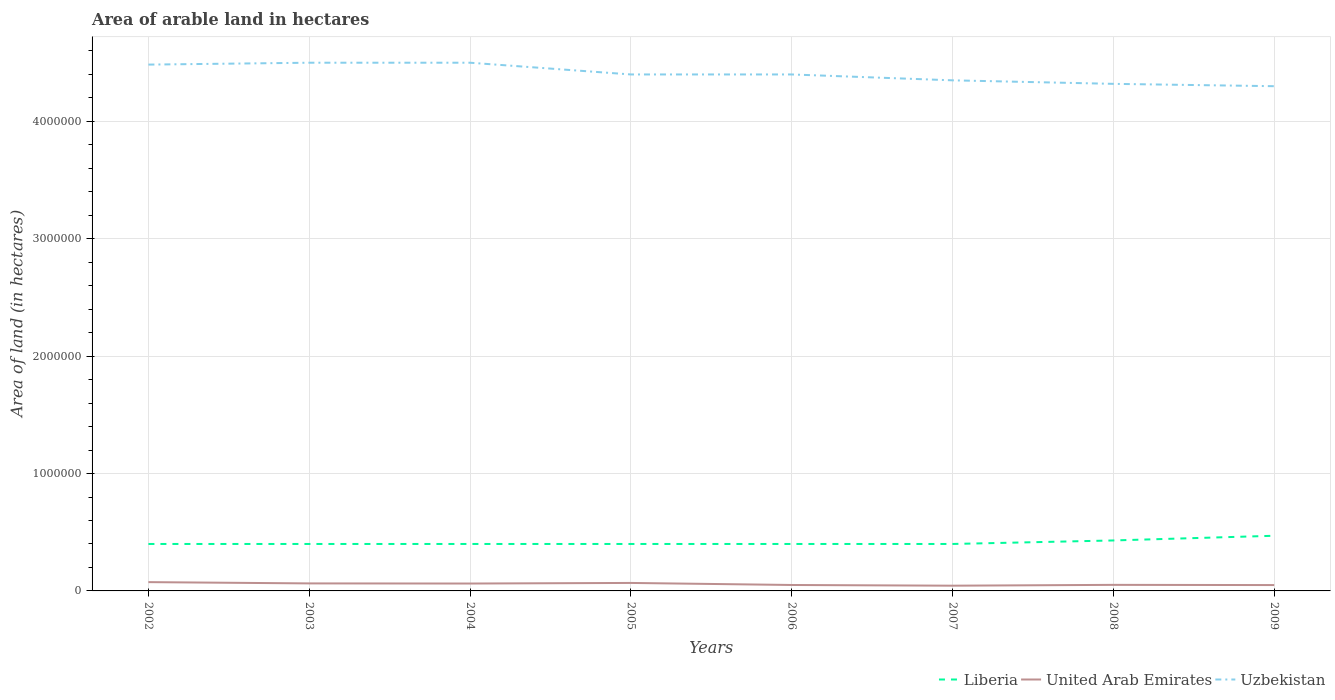Across all years, what is the maximum total arable land in United Arab Emirates?
Ensure brevity in your answer.  4.46e+04. What is the total total arable land in United Arab Emirates in the graph?
Keep it short and to the point. 1700. What is the difference between the highest and the second highest total arable land in Liberia?
Offer a very short reply. 7.00e+04. What is the difference between the highest and the lowest total arable land in Liberia?
Provide a succinct answer. 2. How many lines are there?
Give a very brief answer. 3. What is the difference between two consecutive major ticks on the Y-axis?
Your answer should be compact. 1.00e+06. Does the graph contain any zero values?
Your answer should be compact. No. How many legend labels are there?
Your answer should be compact. 3. How are the legend labels stacked?
Make the answer very short. Horizontal. What is the title of the graph?
Your answer should be compact. Area of arable land in hectares. What is the label or title of the X-axis?
Offer a very short reply. Years. What is the label or title of the Y-axis?
Your answer should be very brief. Area of land (in hectares). What is the Area of land (in hectares) of Liberia in 2002?
Your response must be concise. 4.00e+05. What is the Area of land (in hectares) of United Arab Emirates in 2002?
Keep it short and to the point. 7.50e+04. What is the Area of land (in hectares) of Uzbekistan in 2002?
Keep it short and to the point. 4.48e+06. What is the Area of land (in hectares) in Liberia in 2003?
Provide a succinct answer. 4.00e+05. What is the Area of land (in hectares) in United Arab Emirates in 2003?
Ensure brevity in your answer.  6.40e+04. What is the Area of land (in hectares) of Uzbekistan in 2003?
Keep it short and to the point. 4.50e+06. What is the Area of land (in hectares) in Liberia in 2004?
Provide a succinct answer. 4.00e+05. What is the Area of land (in hectares) in United Arab Emirates in 2004?
Your response must be concise. 6.30e+04. What is the Area of land (in hectares) in Uzbekistan in 2004?
Offer a terse response. 4.50e+06. What is the Area of land (in hectares) of Liberia in 2005?
Offer a terse response. 4.00e+05. What is the Area of land (in hectares) in United Arab Emirates in 2005?
Your response must be concise. 6.80e+04. What is the Area of land (in hectares) in Uzbekistan in 2005?
Provide a succinct answer. 4.40e+06. What is the Area of land (in hectares) in Liberia in 2006?
Your answer should be very brief. 4.00e+05. What is the Area of land (in hectares) of United Arab Emirates in 2006?
Provide a short and direct response. 5.06e+04. What is the Area of land (in hectares) of Uzbekistan in 2006?
Provide a succinct answer. 4.40e+06. What is the Area of land (in hectares) of Liberia in 2007?
Provide a short and direct response. 4.00e+05. What is the Area of land (in hectares) of United Arab Emirates in 2007?
Your response must be concise. 4.46e+04. What is the Area of land (in hectares) in Uzbekistan in 2007?
Provide a succinct answer. 4.35e+06. What is the Area of land (in hectares) of United Arab Emirates in 2008?
Give a very brief answer. 5.16e+04. What is the Area of land (in hectares) in Uzbekistan in 2008?
Provide a short and direct response. 4.32e+06. What is the Area of land (in hectares) in Liberia in 2009?
Ensure brevity in your answer.  4.70e+05. What is the Area of land (in hectares) of United Arab Emirates in 2009?
Offer a terse response. 4.99e+04. What is the Area of land (in hectares) in Uzbekistan in 2009?
Ensure brevity in your answer.  4.30e+06. Across all years, what is the maximum Area of land (in hectares) in United Arab Emirates?
Offer a very short reply. 7.50e+04. Across all years, what is the maximum Area of land (in hectares) in Uzbekistan?
Your answer should be compact. 4.50e+06. Across all years, what is the minimum Area of land (in hectares) of United Arab Emirates?
Ensure brevity in your answer.  4.46e+04. Across all years, what is the minimum Area of land (in hectares) in Uzbekistan?
Provide a short and direct response. 4.30e+06. What is the total Area of land (in hectares) of Liberia in the graph?
Make the answer very short. 3.30e+06. What is the total Area of land (in hectares) in United Arab Emirates in the graph?
Your answer should be compact. 4.67e+05. What is the total Area of land (in hectares) in Uzbekistan in the graph?
Ensure brevity in your answer.  3.53e+07. What is the difference between the Area of land (in hectares) in Liberia in 2002 and that in 2003?
Provide a succinct answer. 0. What is the difference between the Area of land (in hectares) in United Arab Emirates in 2002 and that in 2003?
Give a very brief answer. 1.10e+04. What is the difference between the Area of land (in hectares) of Uzbekistan in 2002 and that in 2003?
Offer a terse response. -1.60e+04. What is the difference between the Area of land (in hectares) of Liberia in 2002 and that in 2004?
Make the answer very short. 0. What is the difference between the Area of land (in hectares) in United Arab Emirates in 2002 and that in 2004?
Give a very brief answer. 1.20e+04. What is the difference between the Area of land (in hectares) of Uzbekistan in 2002 and that in 2004?
Your answer should be very brief. -1.60e+04. What is the difference between the Area of land (in hectares) of United Arab Emirates in 2002 and that in 2005?
Your answer should be very brief. 7000. What is the difference between the Area of land (in hectares) in Uzbekistan in 2002 and that in 2005?
Offer a very short reply. 8.40e+04. What is the difference between the Area of land (in hectares) in Liberia in 2002 and that in 2006?
Your response must be concise. 0. What is the difference between the Area of land (in hectares) in United Arab Emirates in 2002 and that in 2006?
Ensure brevity in your answer.  2.44e+04. What is the difference between the Area of land (in hectares) in Uzbekistan in 2002 and that in 2006?
Make the answer very short. 8.40e+04. What is the difference between the Area of land (in hectares) in United Arab Emirates in 2002 and that in 2007?
Offer a terse response. 3.04e+04. What is the difference between the Area of land (in hectares) in Uzbekistan in 2002 and that in 2007?
Offer a terse response. 1.34e+05. What is the difference between the Area of land (in hectares) in United Arab Emirates in 2002 and that in 2008?
Give a very brief answer. 2.34e+04. What is the difference between the Area of land (in hectares) of Uzbekistan in 2002 and that in 2008?
Offer a terse response. 1.64e+05. What is the difference between the Area of land (in hectares) of United Arab Emirates in 2002 and that in 2009?
Your answer should be very brief. 2.51e+04. What is the difference between the Area of land (in hectares) in Uzbekistan in 2002 and that in 2009?
Your answer should be very brief. 1.84e+05. What is the difference between the Area of land (in hectares) of Liberia in 2003 and that in 2004?
Your response must be concise. 0. What is the difference between the Area of land (in hectares) in Liberia in 2003 and that in 2005?
Ensure brevity in your answer.  0. What is the difference between the Area of land (in hectares) in United Arab Emirates in 2003 and that in 2005?
Your answer should be very brief. -4000. What is the difference between the Area of land (in hectares) in Uzbekistan in 2003 and that in 2005?
Provide a short and direct response. 1.00e+05. What is the difference between the Area of land (in hectares) of United Arab Emirates in 2003 and that in 2006?
Offer a terse response. 1.34e+04. What is the difference between the Area of land (in hectares) in Uzbekistan in 2003 and that in 2006?
Make the answer very short. 1.00e+05. What is the difference between the Area of land (in hectares) of Liberia in 2003 and that in 2007?
Provide a short and direct response. 0. What is the difference between the Area of land (in hectares) of United Arab Emirates in 2003 and that in 2007?
Your response must be concise. 1.94e+04. What is the difference between the Area of land (in hectares) in United Arab Emirates in 2003 and that in 2008?
Provide a short and direct response. 1.24e+04. What is the difference between the Area of land (in hectares) of Uzbekistan in 2003 and that in 2008?
Keep it short and to the point. 1.80e+05. What is the difference between the Area of land (in hectares) of United Arab Emirates in 2003 and that in 2009?
Provide a short and direct response. 1.41e+04. What is the difference between the Area of land (in hectares) in Uzbekistan in 2003 and that in 2009?
Make the answer very short. 2.00e+05. What is the difference between the Area of land (in hectares) in United Arab Emirates in 2004 and that in 2005?
Ensure brevity in your answer.  -5000. What is the difference between the Area of land (in hectares) in Uzbekistan in 2004 and that in 2005?
Make the answer very short. 1.00e+05. What is the difference between the Area of land (in hectares) of United Arab Emirates in 2004 and that in 2006?
Offer a very short reply. 1.24e+04. What is the difference between the Area of land (in hectares) in Liberia in 2004 and that in 2007?
Give a very brief answer. 0. What is the difference between the Area of land (in hectares) in United Arab Emirates in 2004 and that in 2007?
Provide a succinct answer. 1.84e+04. What is the difference between the Area of land (in hectares) in Uzbekistan in 2004 and that in 2007?
Provide a short and direct response. 1.50e+05. What is the difference between the Area of land (in hectares) in Liberia in 2004 and that in 2008?
Ensure brevity in your answer.  -3.00e+04. What is the difference between the Area of land (in hectares) of United Arab Emirates in 2004 and that in 2008?
Keep it short and to the point. 1.14e+04. What is the difference between the Area of land (in hectares) in Uzbekistan in 2004 and that in 2008?
Provide a succinct answer. 1.80e+05. What is the difference between the Area of land (in hectares) in United Arab Emirates in 2004 and that in 2009?
Keep it short and to the point. 1.31e+04. What is the difference between the Area of land (in hectares) in Uzbekistan in 2004 and that in 2009?
Your answer should be compact. 2.00e+05. What is the difference between the Area of land (in hectares) in United Arab Emirates in 2005 and that in 2006?
Offer a terse response. 1.74e+04. What is the difference between the Area of land (in hectares) in United Arab Emirates in 2005 and that in 2007?
Provide a short and direct response. 2.34e+04. What is the difference between the Area of land (in hectares) in Uzbekistan in 2005 and that in 2007?
Offer a very short reply. 5.00e+04. What is the difference between the Area of land (in hectares) in Liberia in 2005 and that in 2008?
Your response must be concise. -3.00e+04. What is the difference between the Area of land (in hectares) in United Arab Emirates in 2005 and that in 2008?
Make the answer very short. 1.64e+04. What is the difference between the Area of land (in hectares) in Liberia in 2005 and that in 2009?
Offer a very short reply. -7.00e+04. What is the difference between the Area of land (in hectares) in United Arab Emirates in 2005 and that in 2009?
Provide a short and direct response. 1.81e+04. What is the difference between the Area of land (in hectares) of United Arab Emirates in 2006 and that in 2007?
Your answer should be very brief. 6000. What is the difference between the Area of land (in hectares) in Liberia in 2006 and that in 2008?
Your response must be concise. -3.00e+04. What is the difference between the Area of land (in hectares) in United Arab Emirates in 2006 and that in 2008?
Your answer should be very brief. -1000. What is the difference between the Area of land (in hectares) in Liberia in 2006 and that in 2009?
Offer a terse response. -7.00e+04. What is the difference between the Area of land (in hectares) of United Arab Emirates in 2006 and that in 2009?
Your answer should be very brief. 700. What is the difference between the Area of land (in hectares) in United Arab Emirates in 2007 and that in 2008?
Offer a terse response. -7000. What is the difference between the Area of land (in hectares) in Uzbekistan in 2007 and that in 2008?
Offer a terse response. 3.00e+04. What is the difference between the Area of land (in hectares) of United Arab Emirates in 2007 and that in 2009?
Provide a short and direct response. -5300. What is the difference between the Area of land (in hectares) in United Arab Emirates in 2008 and that in 2009?
Ensure brevity in your answer.  1700. What is the difference between the Area of land (in hectares) of Liberia in 2002 and the Area of land (in hectares) of United Arab Emirates in 2003?
Provide a succinct answer. 3.36e+05. What is the difference between the Area of land (in hectares) in Liberia in 2002 and the Area of land (in hectares) in Uzbekistan in 2003?
Provide a short and direct response. -4.10e+06. What is the difference between the Area of land (in hectares) of United Arab Emirates in 2002 and the Area of land (in hectares) of Uzbekistan in 2003?
Your response must be concise. -4.42e+06. What is the difference between the Area of land (in hectares) in Liberia in 2002 and the Area of land (in hectares) in United Arab Emirates in 2004?
Offer a terse response. 3.37e+05. What is the difference between the Area of land (in hectares) in Liberia in 2002 and the Area of land (in hectares) in Uzbekistan in 2004?
Make the answer very short. -4.10e+06. What is the difference between the Area of land (in hectares) in United Arab Emirates in 2002 and the Area of land (in hectares) in Uzbekistan in 2004?
Provide a succinct answer. -4.42e+06. What is the difference between the Area of land (in hectares) in Liberia in 2002 and the Area of land (in hectares) in United Arab Emirates in 2005?
Offer a terse response. 3.32e+05. What is the difference between the Area of land (in hectares) of Liberia in 2002 and the Area of land (in hectares) of Uzbekistan in 2005?
Your response must be concise. -4.00e+06. What is the difference between the Area of land (in hectares) in United Arab Emirates in 2002 and the Area of land (in hectares) in Uzbekistan in 2005?
Offer a very short reply. -4.32e+06. What is the difference between the Area of land (in hectares) of Liberia in 2002 and the Area of land (in hectares) of United Arab Emirates in 2006?
Make the answer very short. 3.49e+05. What is the difference between the Area of land (in hectares) of Liberia in 2002 and the Area of land (in hectares) of Uzbekistan in 2006?
Provide a succinct answer. -4.00e+06. What is the difference between the Area of land (in hectares) of United Arab Emirates in 2002 and the Area of land (in hectares) of Uzbekistan in 2006?
Provide a succinct answer. -4.32e+06. What is the difference between the Area of land (in hectares) in Liberia in 2002 and the Area of land (in hectares) in United Arab Emirates in 2007?
Your answer should be compact. 3.55e+05. What is the difference between the Area of land (in hectares) of Liberia in 2002 and the Area of land (in hectares) of Uzbekistan in 2007?
Offer a terse response. -3.95e+06. What is the difference between the Area of land (in hectares) in United Arab Emirates in 2002 and the Area of land (in hectares) in Uzbekistan in 2007?
Offer a very short reply. -4.28e+06. What is the difference between the Area of land (in hectares) of Liberia in 2002 and the Area of land (in hectares) of United Arab Emirates in 2008?
Your answer should be compact. 3.48e+05. What is the difference between the Area of land (in hectares) in Liberia in 2002 and the Area of land (in hectares) in Uzbekistan in 2008?
Your response must be concise. -3.92e+06. What is the difference between the Area of land (in hectares) of United Arab Emirates in 2002 and the Area of land (in hectares) of Uzbekistan in 2008?
Your answer should be compact. -4.24e+06. What is the difference between the Area of land (in hectares) of Liberia in 2002 and the Area of land (in hectares) of United Arab Emirates in 2009?
Keep it short and to the point. 3.50e+05. What is the difference between the Area of land (in hectares) in Liberia in 2002 and the Area of land (in hectares) in Uzbekistan in 2009?
Give a very brief answer. -3.90e+06. What is the difference between the Area of land (in hectares) of United Arab Emirates in 2002 and the Area of land (in hectares) of Uzbekistan in 2009?
Keep it short and to the point. -4.22e+06. What is the difference between the Area of land (in hectares) in Liberia in 2003 and the Area of land (in hectares) in United Arab Emirates in 2004?
Your answer should be compact. 3.37e+05. What is the difference between the Area of land (in hectares) of Liberia in 2003 and the Area of land (in hectares) of Uzbekistan in 2004?
Ensure brevity in your answer.  -4.10e+06. What is the difference between the Area of land (in hectares) of United Arab Emirates in 2003 and the Area of land (in hectares) of Uzbekistan in 2004?
Give a very brief answer. -4.44e+06. What is the difference between the Area of land (in hectares) in Liberia in 2003 and the Area of land (in hectares) in United Arab Emirates in 2005?
Your answer should be compact. 3.32e+05. What is the difference between the Area of land (in hectares) in United Arab Emirates in 2003 and the Area of land (in hectares) in Uzbekistan in 2005?
Ensure brevity in your answer.  -4.34e+06. What is the difference between the Area of land (in hectares) in Liberia in 2003 and the Area of land (in hectares) in United Arab Emirates in 2006?
Your answer should be compact. 3.49e+05. What is the difference between the Area of land (in hectares) in Liberia in 2003 and the Area of land (in hectares) in Uzbekistan in 2006?
Your answer should be very brief. -4.00e+06. What is the difference between the Area of land (in hectares) in United Arab Emirates in 2003 and the Area of land (in hectares) in Uzbekistan in 2006?
Offer a very short reply. -4.34e+06. What is the difference between the Area of land (in hectares) in Liberia in 2003 and the Area of land (in hectares) in United Arab Emirates in 2007?
Offer a terse response. 3.55e+05. What is the difference between the Area of land (in hectares) in Liberia in 2003 and the Area of land (in hectares) in Uzbekistan in 2007?
Your response must be concise. -3.95e+06. What is the difference between the Area of land (in hectares) of United Arab Emirates in 2003 and the Area of land (in hectares) of Uzbekistan in 2007?
Ensure brevity in your answer.  -4.29e+06. What is the difference between the Area of land (in hectares) of Liberia in 2003 and the Area of land (in hectares) of United Arab Emirates in 2008?
Keep it short and to the point. 3.48e+05. What is the difference between the Area of land (in hectares) in Liberia in 2003 and the Area of land (in hectares) in Uzbekistan in 2008?
Your answer should be very brief. -3.92e+06. What is the difference between the Area of land (in hectares) in United Arab Emirates in 2003 and the Area of land (in hectares) in Uzbekistan in 2008?
Your answer should be very brief. -4.26e+06. What is the difference between the Area of land (in hectares) in Liberia in 2003 and the Area of land (in hectares) in United Arab Emirates in 2009?
Give a very brief answer. 3.50e+05. What is the difference between the Area of land (in hectares) of Liberia in 2003 and the Area of land (in hectares) of Uzbekistan in 2009?
Give a very brief answer. -3.90e+06. What is the difference between the Area of land (in hectares) in United Arab Emirates in 2003 and the Area of land (in hectares) in Uzbekistan in 2009?
Your answer should be compact. -4.24e+06. What is the difference between the Area of land (in hectares) in Liberia in 2004 and the Area of land (in hectares) in United Arab Emirates in 2005?
Your answer should be very brief. 3.32e+05. What is the difference between the Area of land (in hectares) of United Arab Emirates in 2004 and the Area of land (in hectares) of Uzbekistan in 2005?
Give a very brief answer. -4.34e+06. What is the difference between the Area of land (in hectares) of Liberia in 2004 and the Area of land (in hectares) of United Arab Emirates in 2006?
Keep it short and to the point. 3.49e+05. What is the difference between the Area of land (in hectares) of Liberia in 2004 and the Area of land (in hectares) of Uzbekistan in 2006?
Give a very brief answer. -4.00e+06. What is the difference between the Area of land (in hectares) in United Arab Emirates in 2004 and the Area of land (in hectares) in Uzbekistan in 2006?
Make the answer very short. -4.34e+06. What is the difference between the Area of land (in hectares) of Liberia in 2004 and the Area of land (in hectares) of United Arab Emirates in 2007?
Provide a short and direct response. 3.55e+05. What is the difference between the Area of land (in hectares) in Liberia in 2004 and the Area of land (in hectares) in Uzbekistan in 2007?
Your answer should be very brief. -3.95e+06. What is the difference between the Area of land (in hectares) of United Arab Emirates in 2004 and the Area of land (in hectares) of Uzbekistan in 2007?
Your answer should be compact. -4.29e+06. What is the difference between the Area of land (in hectares) in Liberia in 2004 and the Area of land (in hectares) in United Arab Emirates in 2008?
Your answer should be very brief. 3.48e+05. What is the difference between the Area of land (in hectares) of Liberia in 2004 and the Area of land (in hectares) of Uzbekistan in 2008?
Provide a succinct answer. -3.92e+06. What is the difference between the Area of land (in hectares) in United Arab Emirates in 2004 and the Area of land (in hectares) in Uzbekistan in 2008?
Ensure brevity in your answer.  -4.26e+06. What is the difference between the Area of land (in hectares) of Liberia in 2004 and the Area of land (in hectares) of United Arab Emirates in 2009?
Ensure brevity in your answer.  3.50e+05. What is the difference between the Area of land (in hectares) in Liberia in 2004 and the Area of land (in hectares) in Uzbekistan in 2009?
Ensure brevity in your answer.  -3.90e+06. What is the difference between the Area of land (in hectares) of United Arab Emirates in 2004 and the Area of land (in hectares) of Uzbekistan in 2009?
Give a very brief answer. -4.24e+06. What is the difference between the Area of land (in hectares) of Liberia in 2005 and the Area of land (in hectares) of United Arab Emirates in 2006?
Your answer should be compact. 3.49e+05. What is the difference between the Area of land (in hectares) in United Arab Emirates in 2005 and the Area of land (in hectares) in Uzbekistan in 2006?
Ensure brevity in your answer.  -4.33e+06. What is the difference between the Area of land (in hectares) of Liberia in 2005 and the Area of land (in hectares) of United Arab Emirates in 2007?
Your response must be concise. 3.55e+05. What is the difference between the Area of land (in hectares) in Liberia in 2005 and the Area of land (in hectares) in Uzbekistan in 2007?
Your response must be concise. -3.95e+06. What is the difference between the Area of land (in hectares) in United Arab Emirates in 2005 and the Area of land (in hectares) in Uzbekistan in 2007?
Your answer should be very brief. -4.28e+06. What is the difference between the Area of land (in hectares) in Liberia in 2005 and the Area of land (in hectares) in United Arab Emirates in 2008?
Offer a very short reply. 3.48e+05. What is the difference between the Area of land (in hectares) in Liberia in 2005 and the Area of land (in hectares) in Uzbekistan in 2008?
Ensure brevity in your answer.  -3.92e+06. What is the difference between the Area of land (in hectares) of United Arab Emirates in 2005 and the Area of land (in hectares) of Uzbekistan in 2008?
Keep it short and to the point. -4.25e+06. What is the difference between the Area of land (in hectares) in Liberia in 2005 and the Area of land (in hectares) in United Arab Emirates in 2009?
Your response must be concise. 3.50e+05. What is the difference between the Area of land (in hectares) in Liberia in 2005 and the Area of land (in hectares) in Uzbekistan in 2009?
Keep it short and to the point. -3.90e+06. What is the difference between the Area of land (in hectares) of United Arab Emirates in 2005 and the Area of land (in hectares) of Uzbekistan in 2009?
Keep it short and to the point. -4.23e+06. What is the difference between the Area of land (in hectares) of Liberia in 2006 and the Area of land (in hectares) of United Arab Emirates in 2007?
Offer a terse response. 3.55e+05. What is the difference between the Area of land (in hectares) of Liberia in 2006 and the Area of land (in hectares) of Uzbekistan in 2007?
Give a very brief answer. -3.95e+06. What is the difference between the Area of land (in hectares) of United Arab Emirates in 2006 and the Area of land (in hectares) of Uzbekistan in 2007?
Ensure brevity in your answer.  -4.30e+06. What is the difference between the Area of land (in hectares) of Liberia in 2006 and the Area of land (in hectares) of United Arab Emirates in 2008?
Your answer should be very brief. 3.48e+05. What is the difference between the Area of land (in hectares) of Liberia in 2006 and the Area of land (in hectares) of Uzbekistan in 2008?
Your response must be concise. -3.92e+06. What is the difference between the Area of land (in hectares) of United Arab Emirates in 2006 and the Area of land (in hectares) of Uzbekistan in 2008?
Your answer should be very brief. -4.27e+06. What is the difference between the Area of land (in hectares) in Liberia in 2006 and the Area of land (in hectares) in United Arab Emirates in 2009?
Your response must be concise. 3.50e+05. What is the difference between the Area of land (in hectares) in Liberia in 2006 and the Area of land (in hectares) in Uzbekistan in 2009?
Your answer should be very brief. -3.90e+06. What is the difference between the Area of land (in hectares) of United Arab Emirates in 2006 and the Area of land (in hectares) of Uzbekistan in 2009?
Offer a very short reply. -4.25e+06. What is the difference between the Area of land (in hectares) in Liberia in 2007 and the Area of land (in hectares) in United Arab Emirates in 2008?
Your answer should be compact. 3.48e+05. What is the difference between the Area of land (in hectares) of Liberia in 2007 and the Area of land (in hectares) of Uzbekistan in 2008?
Keep it short and to the point. -3.92e+06. What is the difference between the Area of land (in hectares) of United Arab Emirates in 2007 and the Area of land (in hectares) of Uzbekistan in 2008?
Offer a very short reply. -4.28e+06. What is the difference between the Area of land (in hectares) in Liberia in 2007 and the Area of land (in hectares) in United Arab Emirates in 2009?
Offer a terse response. 3.50e+05. What is the difference between the Area of land (in hectares) of Liberia in 2007 and the Area of land (in hectares) of Uzbekistan in 2009?
Your answer should be compact. -3.90e+06. What is the difference between the Area of land (in hectares) of United Arab Emirates in 2007 and the Area of land (in hectares) of Uzbekistan in 2009?
Keep it short and to the point. -4.26e+06. What is the difference between the Area of land (in hectares) in Liberia in 2008 and the Area of land (in hectares) in United Arab Emirates in 2009?
Ensure brevity in your answer.  3.80e+05. What is the difference between the Area of land (in hectares) of Liberia in 2008 and the Area of land (in hectares) of Uzbekistan in 2009?
Your response must be concise. -3.87e+06. What is the difference between the Area of land (in hectares) in United Arab Emirates in 2008 and the Area of land (in hectares) in Uzbekistan in 2009?
Give a very brief answer. -4.25e+06. What is the average Area of land (in hectares) in Liberia per year?
Your answer should be compact. 4.12e+05. What is the average Area of land (in hectares) of United Arab Emirates per year?
Keep it short and to the point. 5.83e+04. What is the average Area of land (in hectares) of Uzbekistan per year?
Provide a short and direct response. 4.41e+06. In the year 2002, what is the difference between the Area of land (in hectares) of Liberia and Area of land (in hectares) of United Arab Emirates?
Your answer should be compact. 3.25e+05. In the year 2002, what is the difference between the Area of land (in hectares) in Liberia and Area of land (in hectares) in Uzbekistan?
Offer a very short reply. -4.08e+06. In the year 2002, what is the difference between the Area of land (in hectares) of United Arab Emirates and Area of land (in hectares) of Uzbekistan?
Ensure brevity in your answer.  -4.41e+06. In the year 2003, what is the difference between the Area of land (in hectares) in Liberia and Area of land (in hectares) in United Arab Emirates?
Make the answer very short. 3.36e+05. In the year 2003, what is the difference between the Area of land (in hectares) in Liberia and Area of land (in hectares) in Uzbekistan?
Keep it short and to the point. -4.10e+06. In the year 2003, what is the difference between the Area of land (in hectares) of United Arab Emirates and Area of land (in hectares) of Uzbekistan?
Ensure brevity in your answer.  -4.44e+06. In the year 2004, what is the difference between the Area of land (in hectares) of Liberia and Area of land (in hectares) of United Arab Emirates?
Your answer should be compact. 3.37e+05. In the year 2004, what is the difference between the Area of land (in hectares) of Liberia and Area of land (in hectares) of Uzbekistan?
Provide a short and direct response. -4.10e+06. In the year 2004, what is the difference between the Area of land (in hectares) in United Arab Emirates and Area of land (in hectares) in Uzbekistan?
Provide a succinct answer. -4.44e+06. In the year 2005, what is the difference between the Area of land (in hectares) of Liberia and Area of land (in hectares) of United Arab Emirates?
Offer a very short reply. 3.32e+05. In the year 2005, what is the difference between the Area of land (in hectares) in United Arab Emirates and Area of land (in hectares) in Uzbekistan?
Offer a terse response. -4.33e+06. In the year 2006, what is the difference between the Area of land (in hectares) of Liberia and Area of land (in hectares) of United Arab Emirates?
Offer a terse response. 3.49e+05. In the year 2006, what is the difference between the Area of land (in hectares) in Liberia and Area of land (in hectares) in Uzbekistan?
Ensure brevity in your answer.  -4.00e+06. In the year 2006, what is the difference between the Area of land (in hectares) in United Arab Emirates and Area of land (in hectares) in Uzbekistan?
Offer a very short reply. -4.35e+06. In the year 2007, what is the difference between the Area of land (in hectares) of Liberia and Area of land (in hectares) of United Arab Emirates?
Give a very brief answer. 3.55e+05. In the year 2007, what is the difference between the Area of land (in hectares) in Liberia and Area of land (in hectares) in Uzbekistan?
Keep it short and to the point. -3.95e+06. In the year 2007, what is the difference between the Area of land (in hectares) in United Arab Emirates and Area of land (in hectares) in Uzbekistan?
Offer a terse response. -4.31e+06. In the year 2008, what is the difference between the Area of land (in hectares) in Liberia and Area of land (in hectares) in United Arab Emirates?
Your answer should be very brief. 3.78e+05. In the year 2008, what is the difference between the Area of land (in hectares) in Liberia and Area of land (in hectares) in Uzbekistan?
Your response must be concise. -3.89e+06. In the year 2008, what is the difference between the Area of land (in hectares) of United Arab Emirates and Area of land (in hectares) of Uzbekistan?
Offer a very short reply. -4.27e+06. In the year 2009, what is the difference between the Area of land (in hectares) of Liberia and Area of land (in hectares) of United Arab Emirates?
Give a very brief answer. 4.20e+05. In the year 2009, what is the difference between the Area of land (in hectares) in Liberia and Area of land (in hectares) in Uzbekistan?
Provide a succinct answer. -3.83e+06. In the year 2009, what is the difference between the Area of land (in hectares) of United Arab Emirates and Area of land (in hectares) of Uzbekistan?
Offer a very short reply. -4.25e+06. What is the ratio of the Area of land (in hectares) in United Arab Emirates in 2002 to that in 2003?
Make the answer very short. 1.17. What is the ratio of the Area of land (in hectares) in Uzbekistan in 2002 to that in 2003?
Your answer should be very brief. 1. What is the ratio of the Area of land (in hectares) in Liberia in 2002 to that in 2004?
Make the answer very short. 1. What is the ratio of the Area of land (in hectares) of United Arab Emirates in 2002 to that in 2004?
Keep it short and to the point. 1.19. What is the ratio of the Area of land (in hectares) in United Arab Emirates in 2002 to that in 2005?
Give a very brief answer. 1.1. What is the ratio of the Area of land (in hectares) in Uzbekistan in 2002 to that in 2005?
Your answer should be compact. 1.02. What is the ratio of the Area of land (in hectares) in Liberia in 2002 to that in 2006?
Ensure brevity in your answer.  1. What is the ratio of the Area of land (in hectares) of United Arab Emirates in 2002 to that in 2006?
Keep it short and to the point. 1.48. What is the ratio of the Area of land (in hectares) in Uzbekistan in 2002 to that in 2006?
Ensure brevity in your answer.  1.02. What is the ratio of the Area of land (in hectares) of United Arab Emirates in 2002 to that in 2007?
Offer a very short reply. 1.68. What is the ratio of the Area of land (in hectares) in Uzbekistan in 2002 to that in 2007?
Ensure brevity in your answer.  1.03. What is the ratio of the Area of land (in hectares) in Liberia in 2002 to that in 2008?
Keep it short and to the point. 0.93. What is the ratio of the Area of land (in hectares) in United Arab Emirates in 2002 to that in 2008?
Keep it short and to the point. 1.45. What is the ratio of the Area of land (in hectares) in Uzbekistan in 2002 to that in 2008?
Offer a very short reply. 1.04. What is the ratio of the Area of land (in hectares) in Liberia in 2002 to that in 2009?
Your answer should be compact. 0.85. What is the ratio of the Area of land (in hectares) in United Arab Emirates in 2002 to that in 2009?
Keep it short and to the point. 1.5. What is the ratio of the Area of land (in hectares) in Uzbekistan in 2002 to that in 2009?
Your answer should be very brief. 1.04. What is the ratio of the Area of land (in hectares) in Liberia in 2003 to that in 2004?
Ensure brevity in your answer.  1. What is the ratio of the Area of land (in hectares) in United Arab Emirates in 2003 to that in 2004?
Your answer should be compact. 1.02. What is the ratio of the Area of land (in hectares) of Uzbekistan in 2003 to that in 2004?
Give a very brief answer. 1. What is the ratio of the Area of land (in hectares) of Liberia in 2003 to that in 2005?
Give a very brief answer. 1. What is the ratio of the Area of land (in hectares) of Uzbekistan in 2003 to that in 2005?
Your response must be concise. 1.02. What is the ratio of the Area of land (in hectares) of United Arab Emirates in 2003 to that in 2006?
Your answer should be compact. 1.26. What is the ratio of the Area of land (in hectares) of Uzbekistan in 2003 to that in 2006?
Your answer should be compact. 1.02. What is the ratio of the Area of land (in hectares) in United Arab Emirates in 2003 to that in 2007?
Provide a succinct answer. 1.44. What is the ratio of the Area of land (in hectares) of Uzbekistan in 2003 to that in 2007?
Provide a succinct answer. 1.03. What is the ratio of the Area of land (in hectares) of Liberia in 2003 to that in 2008?
Offer a terse response. 0.93. What is the ratio of the Area of land (in hectares) in United Arab Emirates in 2003 to that in 2008?
Make the answer very short. 1.24. What is the ratio of the Area of land (in hectares) in Uzbekistan in 2003 to that in 2008?
Provide a succinct answer. 1.04. What is the ratio of the Area of land (in hectares) in Liberia in 2003 to that in 2009?
Make the answer very short. 0.85. What is the ratio of the Area of land (in hectares) of United Arab Emirates in 2003 to that in 2009?
Your answer should be compact. 1.28. What is the ratio of the Area of land (in hectares) in Uzbekistan in 2003 to that in 2009?
Your response must be concise. 1.05. What is the ratio of the Area of land (in hectares) of Liberia in 2004 to that in 2005?
Your answer should be very brief. 1. What is the ratio of the Area of land (in hectares) of United Arab Emirates in 2004 to that in 2005?
Offer a very short reply. 0.93. What is the ratio of the Area of land (in hectares) of Uzbekistan in 2004 to that in 2005?
Provide a succinct answer. 1.02. What is the ratio of the Area of land (in hectares) of United Arab Emirates in 2004 to that in 2006?
Give a very brief answer. 1.25. What is the ratio of the Area of land (in hectares) of Uzbekistan in 2004 to that in 2006?
Make the answer very short. 1.02. What is the ratio of the Area of land (in hectares) in Liberia in 2004 to that in 2007?
Keep it short and to the point. 1. What is the ratio of the Area of land (in hectares) in United Arab Emirates in 2004 to that in 2007?
Your answer should be compact. 1.41. What is the ratio of the Area of land (in hectares) of Uzbekistan in 2004 to that in 2007?
Offer a very short reply. 1.03. What is the ratio of the Area of land (in hectares) of Liberia in 2004 to that in 2008?
Make the answer very short. 0.93. What is the ratio of the Area of land (in hectares) in United Arab Emirates in 2004 to that in 2008?
Offer a terse response. 1.22. What is the ratio of the Area of land (in hectares) of Uzbekistan in 2004 to that in 2008?
Provide a succinct answer. 1.04. What is the ratio of the Area of land (in hectares) in Liberia in 2004 to that in 2009?
Provide a succinct answer. 0.85. What is the ratio of the Area of land (in hectares) of United Arab Emirates in 2004 to that in 2009?
Your response must be concise. 1.26. What is the ratio of the Area of land (in hectares) in Uzbekistan in 2004 to that in 2009?
Provide a short and direct response. 1.05. What is the ratio of the Area of land (in hectares) of United Arab Emirates in 2005 to that in 2006?
Keep it short and to the point. 1.34. What is the ratio of the Area of land (in hectares) in Uzbekistan in 2005 to that in 2006?
Make the answer very short. 1. What is the ratio of the Area of land (in hectares) of Liberia in 2005 to that in 2007?
Your answer should be compact. 1. What is the ratio of the Area of land (in hectares) in United Arab Emirates in 2005 to that in 2007?
Offer a very short reply. 1.52. What is the ratio of the Area of land (in hectares) in Uzbekistan in 2005 to that in 2007?
Offer a very short reply. 1.01. What is the ratio of the Area of land (in hectares) of Liberia in 2005 to that in 2008?
Offer a terse response. 0.93. What is the ratio of the Area of land (in hectares) in United Arab Emirates in 2005 to that in 2008?
Offer a terse response. 1.32. What is the ratio of the Area of land (in hectares) in Uzbekistan in 2005 to that in 2008?
Keep it short and to the point. 1.02. What is the ratio of the Area of land (in hectares) of Liberia in 2005 to that in 2009?
Give a very brief answer. 0.85. What is the ratio of the Area of land (in hectares) of United Arab Emirates in 2005 to that in 2009?
Give a very brief answer. 1.36. What is the ratio of the Area of land (in hectares) in Uzbekistan in 2005 to that in 2009?
Your answer should be compact. 1.02. What is the ratio of the Area of land (in hectares) of Liberia in 2006 to that in 2007?
Make the answer very short. 1. What is the ratio of the Area of land (in hectares) in United Arab Emirates in 2006 to that in 2007?
Make the answer very short. 1.13. What is the ratio of the Area of land (in hectares) in Uzbekistan in 2006 to that in 2007?
Offer a terse response. 1.01. What is the ratio of the Area of land (in hectares) of Liberia in 2006 to that in 2008?
Offer a terse response. 0.93. What is the ratio of the Area of land (in hectares) in United Arab Emirates in 2006 to that in 2008?
Provide a short and direct response. 0.98. What is the ratio of the Area of land (in hectares) in Uzbekistan in 2006 to that in 2008?
Your answer should be very brief. 1.02. What is the ratio of the Area of land (in hectares) of Liberia in 2006 to that in 2009?
Make the answer very short. 0.85. What is the ratio of the Area of land (in hectares) in Uzbekistan in 2006 to that in 2009?
Provide a short and direct response. 1.02. What is the ratio of the Area of land (in hectares) in Liberia in 2007 to that in 2008?
Provide a short and direct response. 0.93. What is the ratio of the Area of land (in hectares) in United Arab Emirates in 2007 to that in 2008?
Make the answer very short. 0.86. What is the ratio of the Area of land (in hectares) in Liberia in 2007 to that in 2009?
Offer a very short reply. 0.85. What is the ratio of the Area of land (in hectares) of United Arab Emirates in 2007 to that in 2009?
Offer a very short reply. 0.89. What is the ratio of the Area of land (in hectares) in Uzbekistan in 2007 to that in 2009?
Provide a short and direct response. 1.01. What is the ratio of the Area of land (in hectares) of Liberia in 2008 to that in 2009?
Provide a short and direct response. 0.91. What is the ratio of the Area of land (in hectares) in United Arab Emirates in 2008 to that in 2009?
Ensure brevity in your answer.  1.03. What is the ratio of the Area of land (in hectares) of Uzbekistan in 2008 to that in 2009?
Your response must be concise. 1. What is the difference between the highest and the second highest Area of land (in hectares) in United Arab Emirates?
Your answer should be compact. 7000. What is the difference between the highest and the lowest Area of land (in hectares) of Liberia?
Provide a short and direct response. 7.00e+04. What is the difference between the highest and the lowest Area of land (in hectares) of United Arab Emirates?
Your answer should be very brief. 3.04e+04. 